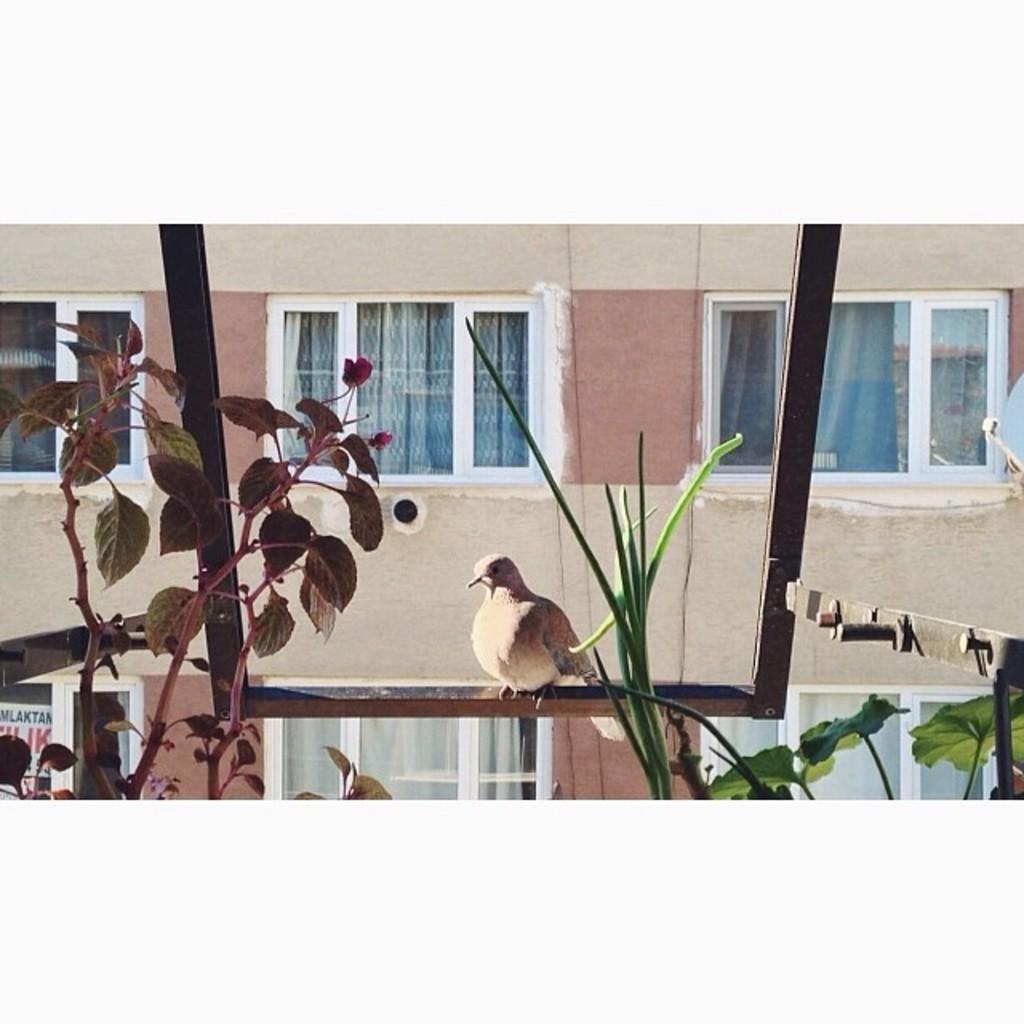Please provide a concise description of this image. In front of the image there are branches with leaves. Behind them there is a bird standing on an iron object. Behind the bird there is a wall with glass windows. Behind the windows there are curtains. 